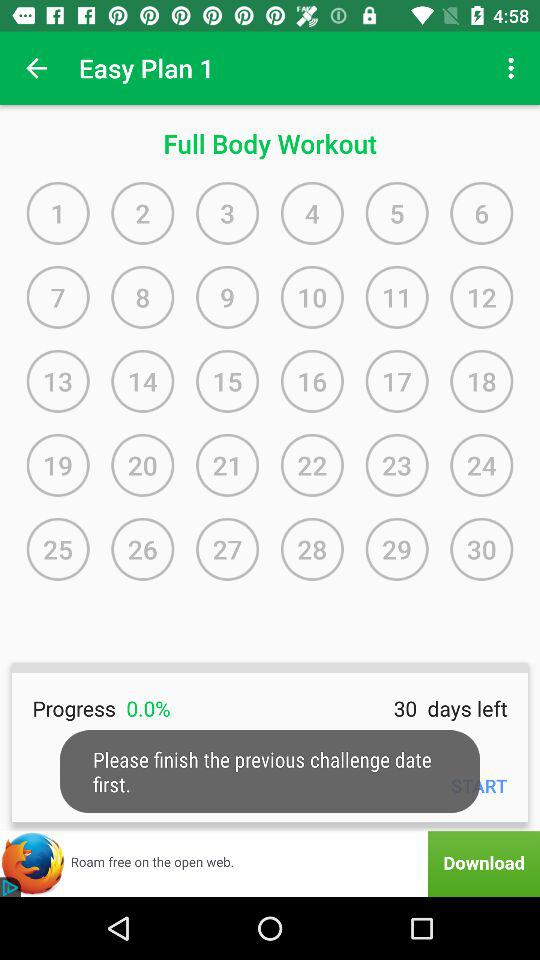Which workout numbers are selected?
When the provided information is insufficient, respond with <no answer>. <no answer> 